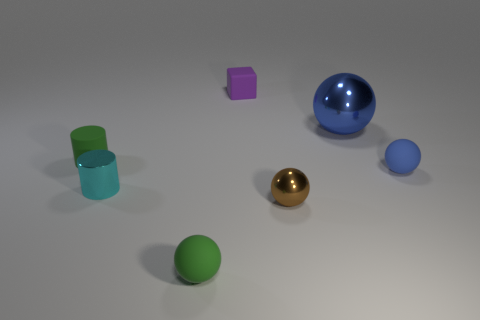The green object in front of the tiny shiny thing that is to the right of the tiny shiny cylinder is what shape? The green object is a sphere. It’s important to note that in these types of visual identification tasks, perspective can play a role in how we interpret objects. Here, based on the image provided, the green object appears spherical, with its distinct, fully rounded shape that is consistent from all visible angles. 